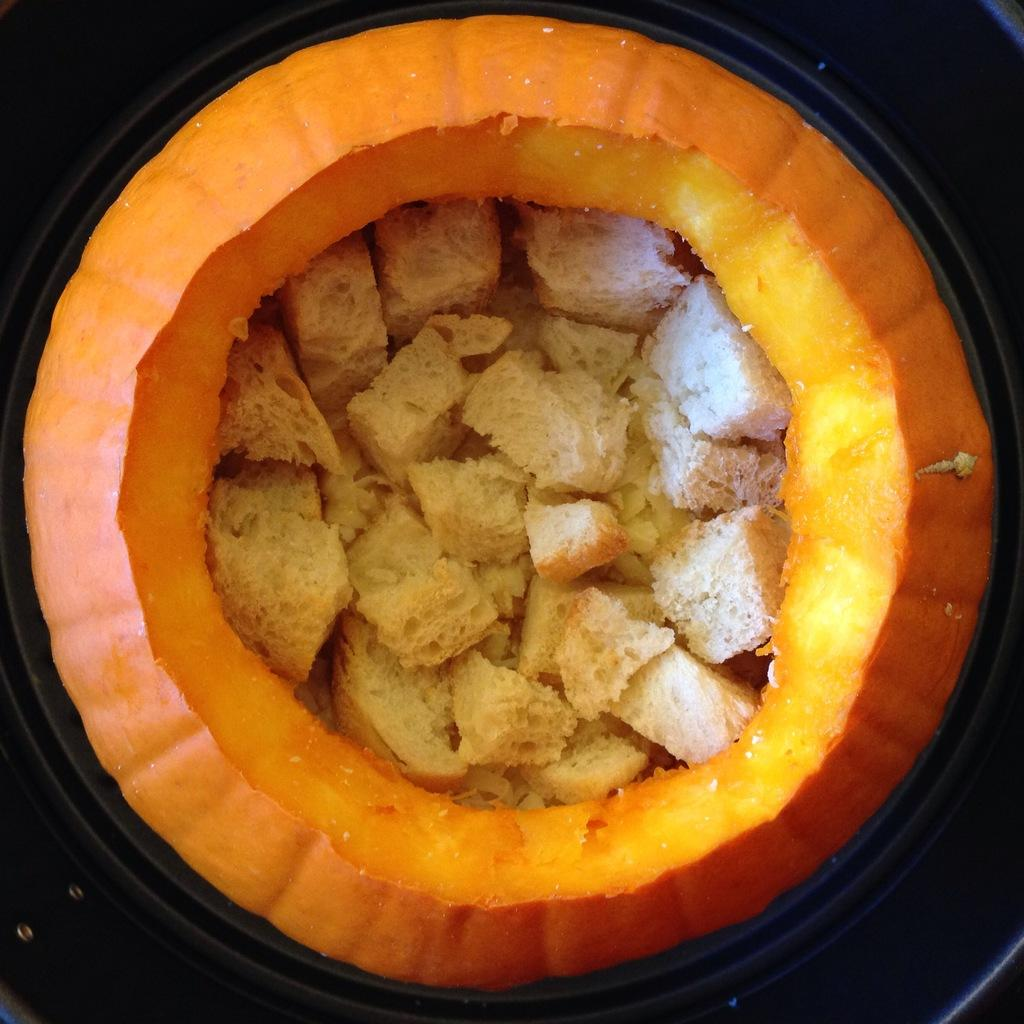What is the main object in the image? There is a pumpkin in the image. What is inside the pumpkin? There are pieces of bread in the pumpkin. What color is the paint on the person's face in the image? There is no person or paint present in the image; it only features a pumpkin with pieces of bread inside. 